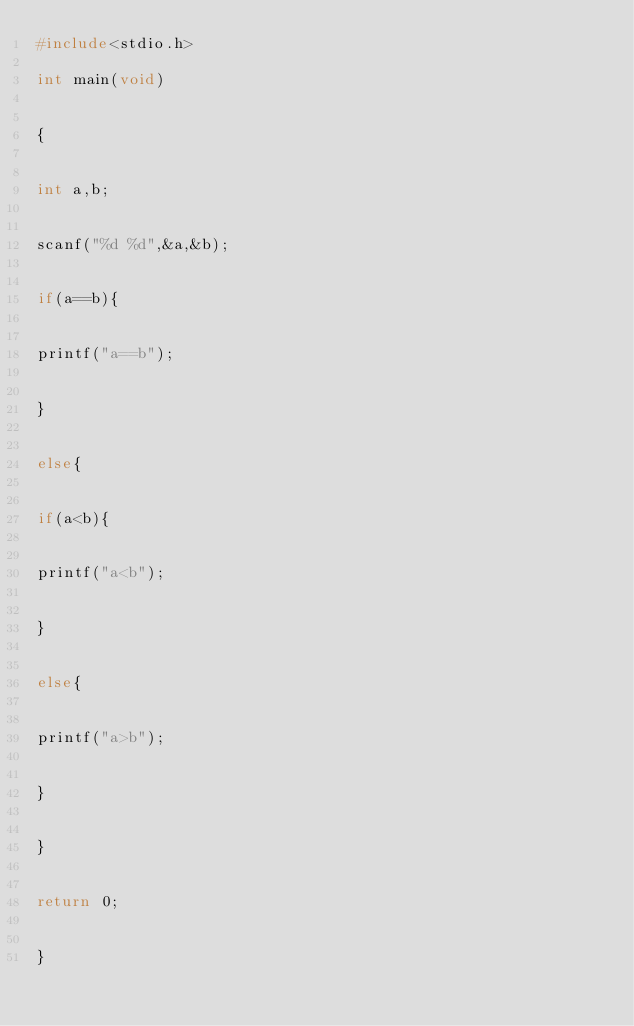<code> <loc_0><loc_0><loc_500><loc_500><_C_>#include<stdio.h>

int main(void)


{


int a,b;


scanf("%d %d",&a,&b);


if(a==b){


printf("a==b");


}


else{


if(a<b){


printf("a<b");


}


else{


printf("a>b");


}


}


return 0;


}</code> 